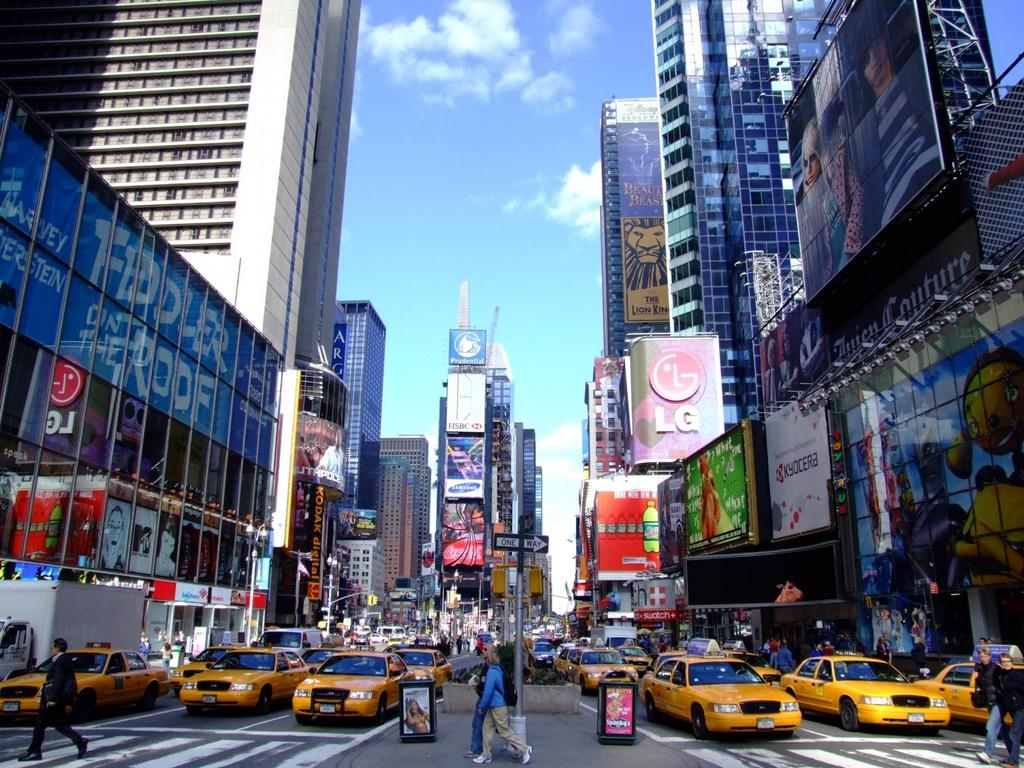<image>
Share a concise interpretation of the image provided. Several cabs are on the street, in a busy city where there are multiple businesses such as Prudential and LG. 